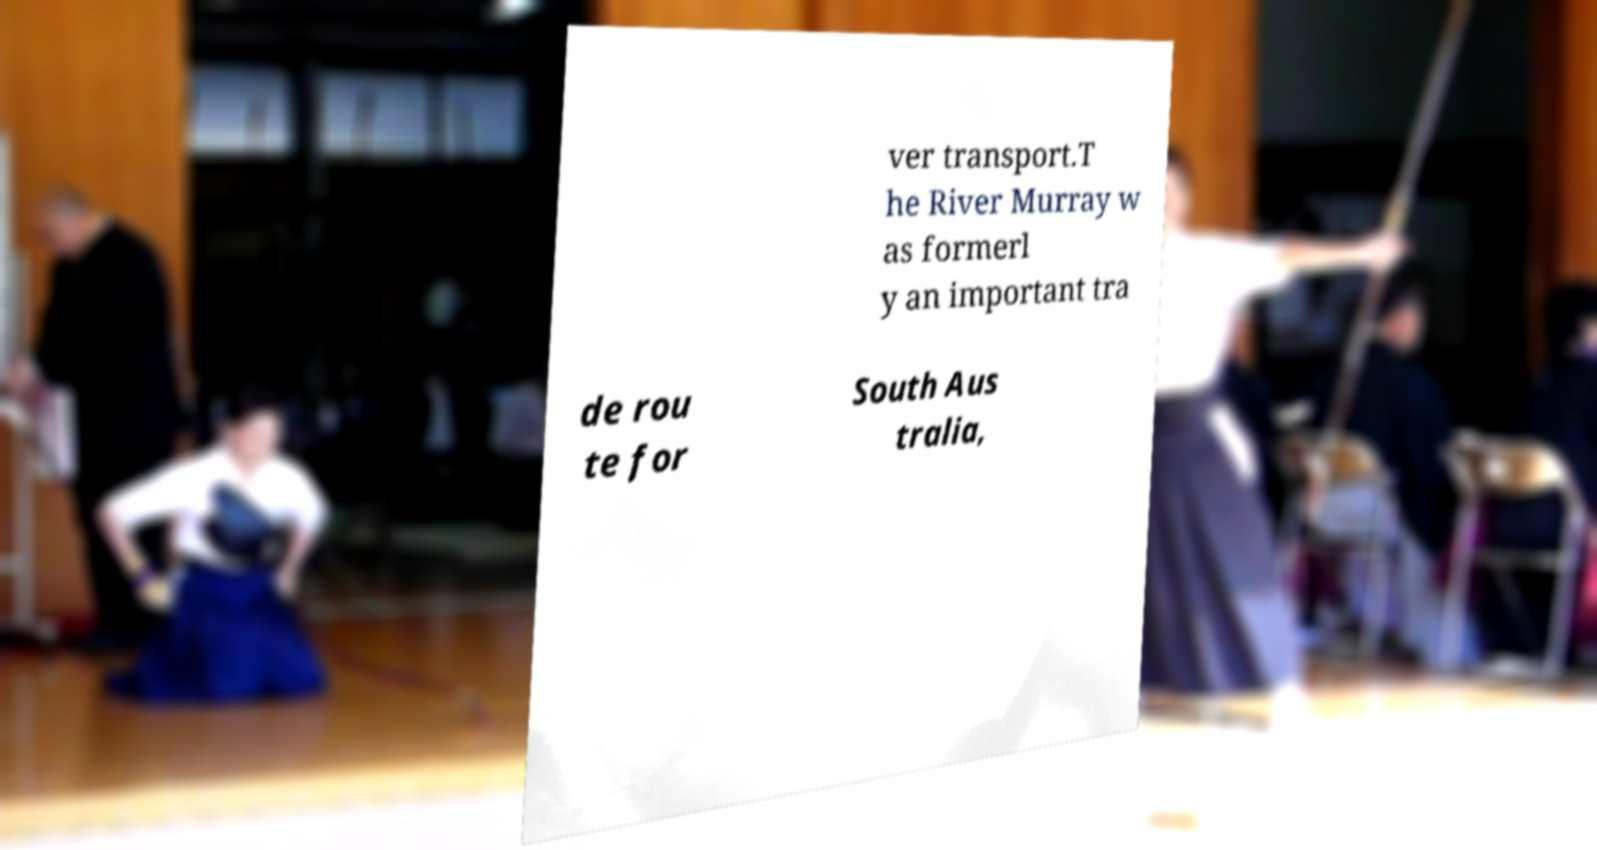Can you read and provide the text displayed in the image?This photo seems to have some interesting text. Can you extract and type it out for me? ver transport.T he River Murray w as formerl y an important tra de rou te for South Aus tralia, 